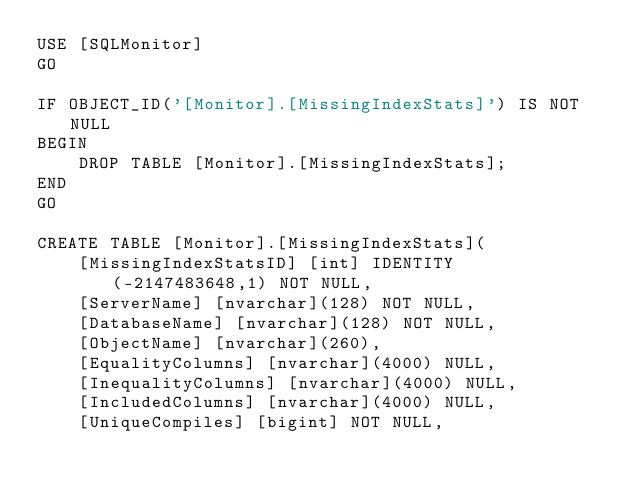Convert code to text. <code><loc_0><loc_0><loc_500><loc_500><_SQL_>USE [SQLMonitor]
GO

IF OBJECT_ID('[Monitor].[MissingIndexStats]') IS NOT NULL
BEGIN
    DROP TABLE [Monitor].[MissingIndexStats];
END
GO

CREATE TABLE [Monitor].[MissingIndexStats](
	[MissingIndexStatsID] [int] IDENTITY(-2147483648,1) NOT NULL,
	[ServerName] [nvarchar](128) NOT NULL,
    [DatabaseName] [nvarchar](128) NOT NULL,
    [ObjectName] [nvarchar](260),
    [EqualityColumns] [nvarchar](4000) NULL,
	[InequalityColumns] [nvarchar](4000) NULL,
	[IncludedColumns] [nvarchar](4000) NULL,
	[UniqueCompiles] [bigint] NOT NULL,</code> 